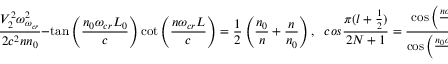Convert formula to latex. <formula><loc_0><loc_0><loc_500><loc_500>\frac { V _ { 2 } ^ { 2 } \omega _ { \omega _ { c r } } ^ { 2 } } { 2 c ^ { 2 } n n _ { 0 } } - \tan \left ( \frac { n _ { 0 } \omega _ { c r } L _ { 0 } } { c } \right ) \cot \left ( \frac { n \omega _ { c r } L } { c } \right ) = \frac { 1 } { 2 } \left ( \frac { n _ { 0 } } { n } + \frac { n } { n _ { 0 } } \right ) , \quad , \cos \frac { \pi ( l + \frac { 1 } { 2 } ) } { 2 N + 1 } = \frac { \cos \left ( \frac { n \omega _ { c r } L } { c } \right ) } { \cos \left ( \frac { n _ { 0 } \omega _ { c r } L _ { 0 } } { c } \right ) }</formula> 